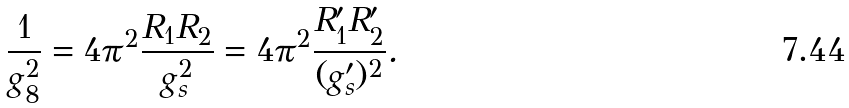Convert formula to latex. <formula><loc_0><loc_0><loc_500><loc_500>\frac { 1 } { g _ { 8 } ^ { 2 } } = 4 \pi ^ { 2 } \frac { R _ { 1 } R _ { 2 } } { g _ { s } ^ { 2 } } = 4 \pi ^ { 2 } \frac { R _ { 1 } ^ { \prime } R _ { 2 } ^ { \prime } } { ( g _ { s } ^ { \prime } ) ^ { 2 } } .</formula> 